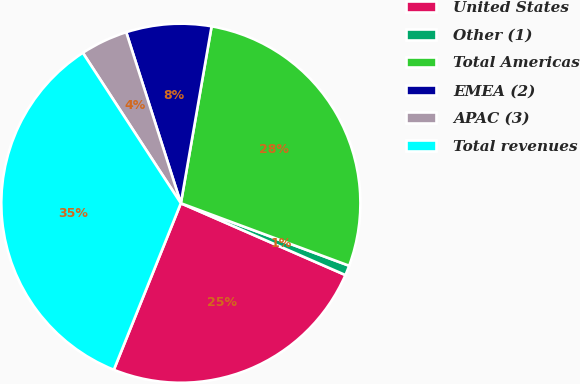Convert chart to OTSL. <chart><loc_0><loc_0><loc_500><loc_500><pie_chart><fcel>United States<fcel>Other (1)<fcel>Total Americas<fcel>EMEA (2)<fcel>APAC (3)<fcel>Total revenues<nl><fcel>24.54%<fcel>0.89%<fcel>27.92%<fcel>7.66%<fcel>4.27%<fcel>34.72%<nl></chart> 